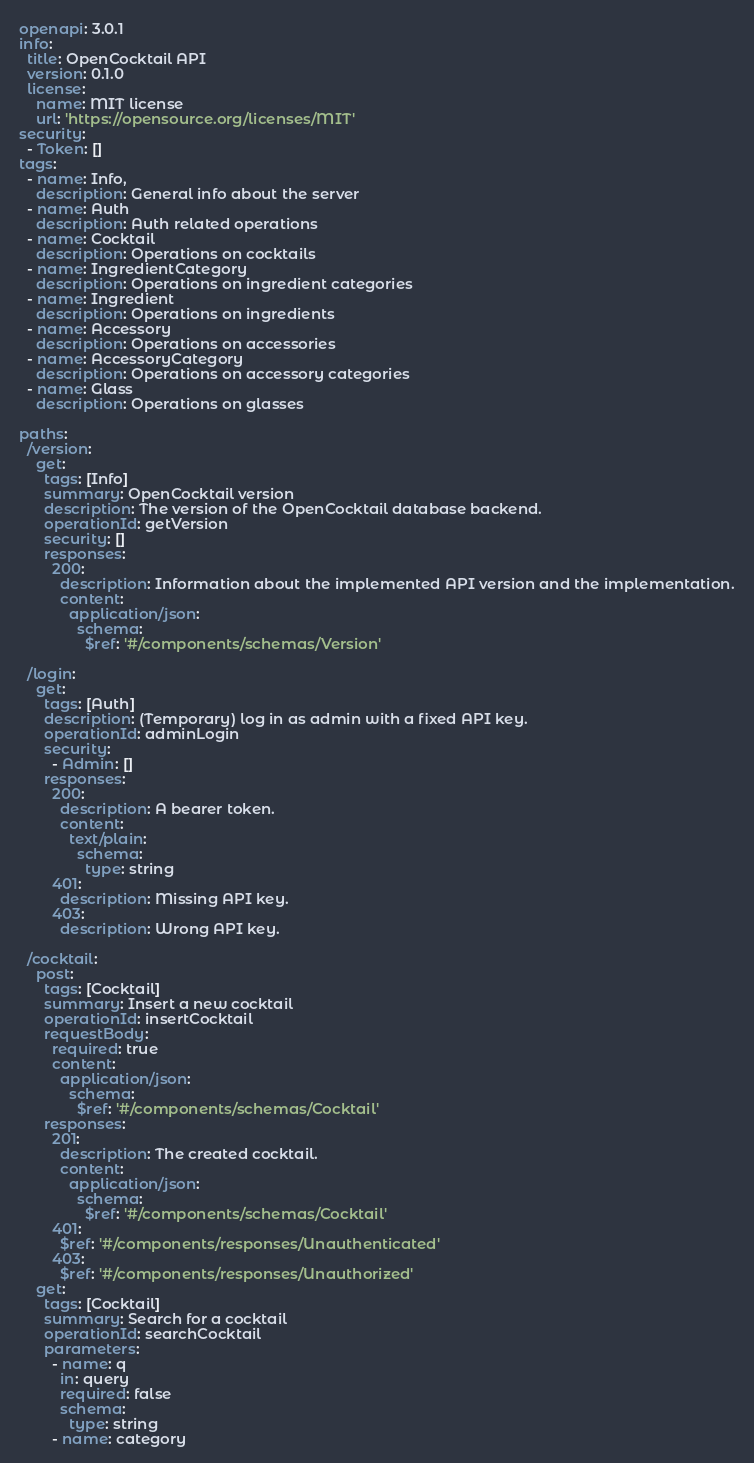Convert code to text. <code><loc_0><loc_0><loc_500><loc_500><_YAML_>openapi: 3.0.1
info:
  title: OpenCocktail API
  version: 0.1.0
  license:
    name: MIT license
    url: 'https://opensource.org/licenses/MIT'
security:
  - Token: []
tags:
  - name: Info,
    description: General info about the server
  - name: Auth
    description: Auth related operations
  - name: Cocktail
    description: Operations on cocktails
  - name: IngredientCategory
    description: Operations on ingredient categories
  - name: Ingredient
    description: Operations on ingredients
  - name: Accessory
    description: Operations on accessories
  - name: AccessoryCategory
    description: Operations on accessory categories
  - name: Glass
    description: Operations on glasses

paths:
  /version:
    get:
      tags: [Info]
      summary: OpenCocktail version
      description: The version of the OpenCocktail database backend.
      operationId: getVersion
      security: []
      responses:
        200:
          description: Information about the implemented API version and the implementation.
          content:
            application/json:
              schema:
                $ref: '#/components/schemas/Version'

  /login:
    get:
      tags: [Auth]
      description: (Temporary) log in as admin with a fixed API key.
      operationId: adminLogin
      security:
        - Admin: []
      responses:
        200:
          description: A bearer token.
          content:
            text/plain:
              schema:
                type: string
        401:
          description: Missing API key.
        403:
          description: Wrong API key.

  /cocktail:
    post:
      tags: [Cocktail]
      summary: Insert a new cocktail
      operationId: insertCocktail
      requestBody:
        required: true
        content:
          application/json:
            schema:
              $ref: '#/components/schemas/Cocktail'
      responses:
        201:
          description: The created cocktail.
          content:
            application/json:
              schema:
                $ref: '#/components/schemas/Cocktail'
        401:
          $ref: '#/components/responses/Unauthenticated'
        403:
          $ref: '#/components/responses/Unauthorized'
    get:
      tags: [Cocktail]
      summary: Search for a cocktail
      operationId: searchCocktail
      parameters:
        - name: q
          in: query
          required: false
          schema:
            type: string
        - name: category</code> 